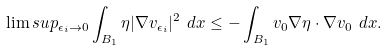<formula> <loc_0><loc_0><loc_500><loc_500>\lim s u p _ { \epsilon _ { i } \to 0 } \int _ { B _ { 1 } } \eta | \nabla v _ { \epsilon _ { i } } | ^ { 2 } \ d x \leq - \int _ { B _ { 1 } } v _ { 0 } \nabla \eta \cdot \nabla v _ { 0 } \ d x .</formula> 